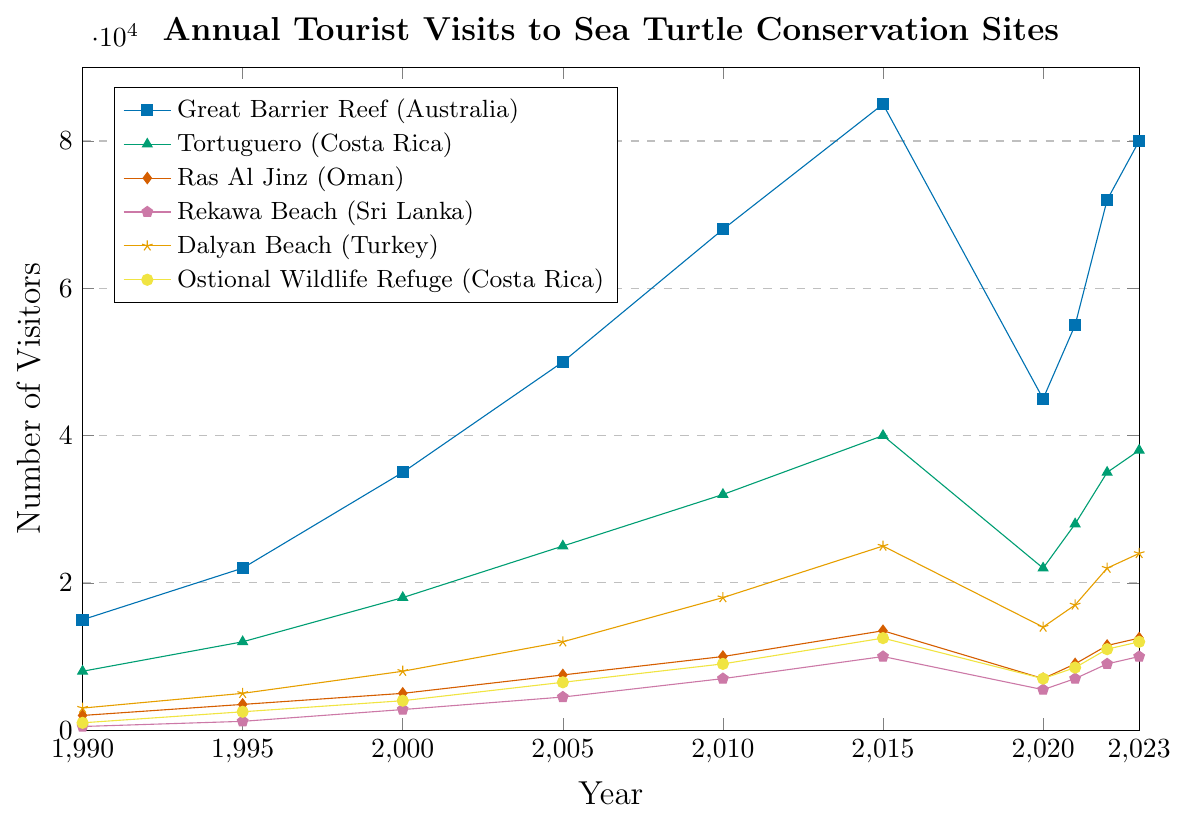Which site had the highest number of tourist visits in 2015? In 2015, Great Barrier Reef had 85000 visitors, the highest among all sites listed.
Answer: Great Barrier Reef How did the number of visitors to Ras Al Jinz (Oman) change from 2005 to 2015? In 2005, Ras Al Jinz had 7500 visitors, and in 2015, it had 13500 visitors. The change is 13500 - 7500 = 6000.
Answer: Increased by 6000 Compare the number of visitors at Dalyan Beach (Turkey) in 2020 and 2023. In 2020, Dalyan Beach had 14000 visitors, and in 2023, it had 24000 visitors. Since 24000 > 14000, it had more visitors in 2023.
Answer: More visitors in 2023 What is the average number of visitors to Rekawa Beach (Sri Lanka) in 1990 and 1995? In 1990, Rekawa Beach had 500 visitors, and in 1995, it had 1200 visitors. The average is (500 + 1200) / 2 = 1700 / 2 = 850.
Answer: 850 What trend can be observed for the number of visitors to the Great Barrier Reef (Australia) from 2015 to 2020, and then to 2023? From 2015 to 2020, the visitors decreased from 85000 to 45000. From 2020 to 2023, the visitors increased from 45000 to 80000.
Answer: Decreased and then increased Between 2021 and 2022, which site experienced the highest increase in visitor numbers? Calculate the difference for each site: 
- Great Barrier Reef: 72000 - 55000 = 17000
- Tortuguero: 35000 - 28000 = 7000
- Ras Al Jinz: 11500 - 9000 = 2500
- Rekawa Beach: 9000 - 7000 = 2000
- Dalyan Beach: 22000 - 17000 = 5000
- Ostional Wildlife Refuge: 11000 - 8500 = 2500
Great Barrier Reef experienced the highest increase of 17000.
Answer: Great Barrier Reef What are the visual trends for Tortuguero (Costa Rica) from 1990 to 2023? From 1990 to 2015, the number of visitors increased steadily from 8000 to 40000. In 2020, there was a drop to 22000, but the numbers increased again to 38000 by 2023.
Answer: Increased, dropped in 2020, then increased again Comparing 1990 and 2023, which site had the smallest absolute increase in visitors? Calculate the absolute increase for each site:
- Great Barrier Reef: 80000 - 15000 = 65000
- Tortuguero: 38000 - 8000 = 30000
- Ras Al Jinz: 12500 - 2000 = 10500
- Rekawa Beach: 10000 - 500 = 9500
- Dalyan Beach: 24000 - 3000 = 21000
- Ostional Wildlife Refuge: 12000 - 1000 = 11000
Rekawa Beach had the smallest increase of 9500.
Answer: Rekawa Beach Which conservation site's visitor numbers showed the least fluctuation between 1990 and 2023? Comparing the consistency and range of fluctuations in the visitor numbers:
- Great Barrier Reef shows large increases and a notable drop in 2020.
- Tortuguero also shows a notable drop in 2020.
- Ras Al Jinz shows a steady increase with moderate fluctuation.
- Rekawa Beach shows a relatively smaller range of fluctuation.
- Dalyan Beach has a significant increase with a drop in 2020.
- Ostional Wildlife Refuge shows steady growth with moderate fluctuations.
Ras Al Jinz showed the most consistent increase and the least fluctuation.
Answer: Ras Al Jinz 